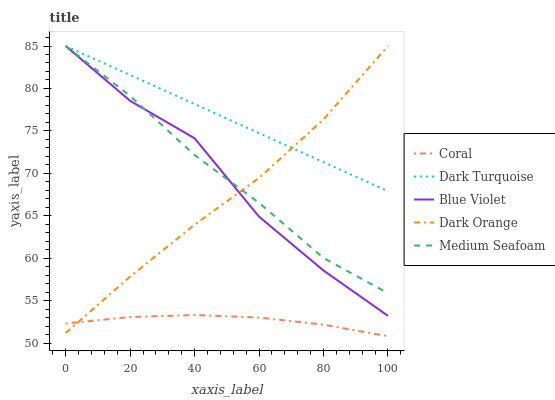Does Coral have the minimum area under the curve?
Answer yes or no. Yes. Does Dark Turquoise have the maximum area under the curve?
Answer yes or no. Yes. Does Medium Seafoam have the minimum area under the curve?
Answer yes or no. No. Does Medium Seafoam have the maximum area under the curve?
Answer yes or no. No. Is Dark Turquoise the smoothest?
Answer yes or no. Yes. Is Blue Violet the roughest?
Answer yes or no. Yes. Is Coral the smoothest?
Answer yes or no. No. Is Coral the roughest?
Answer yes or no. No. Does Coral have the lowest value?
Answer yes or no. Yes. Does Medium Seafoam have the lowest value?
Answer yes or no. No. Does Dark Orange have the highest value?
Answer yes or no. Yes. Does Coral have the highest value?
Answer yes or no. No. Is Coral less than Medium Seafoam?
Answer yes or no. Yes. Is Dark Turquoise greater than Coral?
Answer yes or no. Yes. Does Dark Orange intersect Medium Seafoam?
Answer yes or no. Yes. Is Dark Orange less than Medium Seafoam?
Answer yes or no. No. Is Dark Orange greater than Medium Seafoam?
Answer yes or no. No. Does Coral intersect Medium Seafoam?
Answer yes or no. No. 